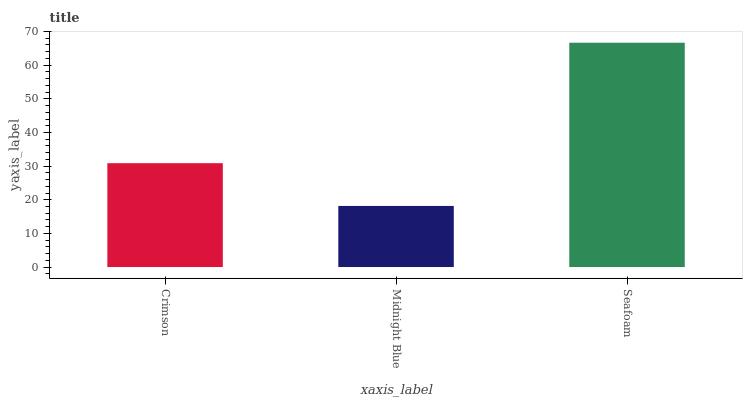Is Midnight Blue the minimum?
Answer yes or no. Yes. Is Seafoam the maximum?
Answer yes or no. Yes. Is Seafoam the minimum?
Answer yes or no. No. Is Midnight Blue the maximum?
Answer yes or no. No. Is Seafoam greater than Midnight Blue?
Answer yes or no. Yes. Is Midnight Blue less than Seafoam?
Answer yes or no. Yes. Is Midnight Blue greater than Seafoam?
Answer yes or no. No. Is Seafoam less than Midnight Blue?
Answer yes or no. No. Is Crimson the high median?
Answer yes or no. Yes. Is Crimson the low median?
Answer yes or no. Yes. Is Midnight Blue the high median?
Answer yes or no. No. Is Seafoam the low median?
Answer yes or no. No. 